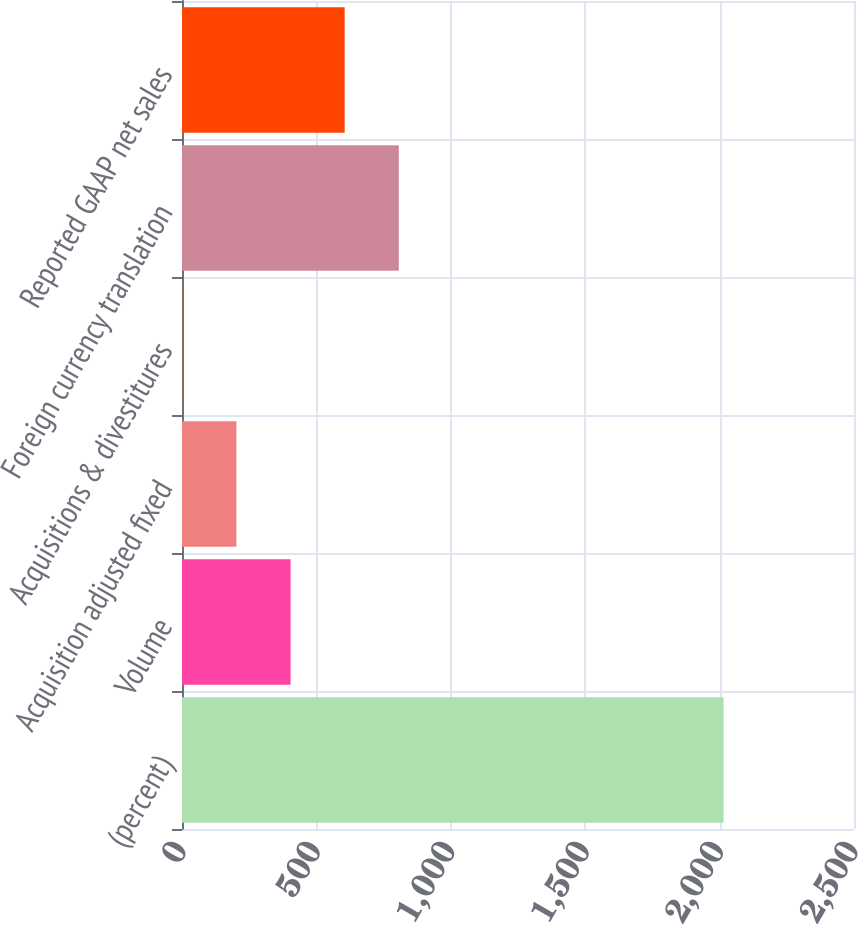Convert chart to OTSL. <chart><loc_0><loc_0><loc_500><loc_500><bar_chart><fcel>(percent)<fcel>Volume<fcel>Acquisition adjusted fixed<fcel>Acquisitions & divestitures<fcel>Foreign currency translation<fcel>Reported GAAP net sales<nl><fcel>2015<fcel>403.8<fcel>202.4<fcel>1<fcel>806.6<fcel>605.2<nl></chart> 